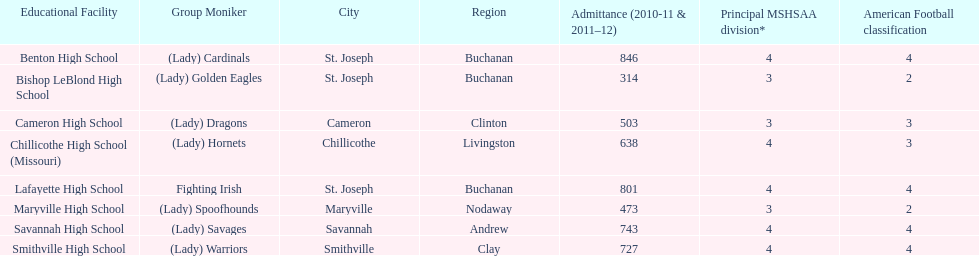What is the number of football classes lafayette high school has? 4. 